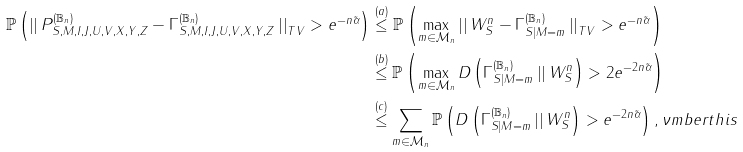Convert formula to latex. <formula><loc_0><loc_0><loc_500><loc_500>\mathbb { P } \left ( \left | \right | P ^ { ( \mathbb { B } _ { n } ) } _ { S , M , I , J , U , V , X , Y , Z } - \Gamma ^ { ( \mathbb { B } _ { n } ) } _ { S , M , I , J , U , V , X , Y , Z } \left | \right | _ { T V } > e ^ { - n \tilde { \alpha } } \right ) & \stackrel { ( a ) } \leq \mathbb { P } \left ( \max _ { m \in \mathcal { M } _ { n } } \left | \right | W _ { S } ^ { n } - \Gamma ^ { ( \mathbb { B } _ { n } ) } _ { S | M = m } \left | \right | _ { T V } > e ^ { - n \tilde { \alpha } } \right ) \\ & \stackrel { ( b ) } \leq \mathbb { P } \left ( \max _ { m \in \mathcal { M } _ { n } } D \left ( \Gamma ^ { ( \mathbb { B } _ { n } ) } _ { S | M = m } \left | \right | W _ { S } ^ { n } \right ) > 2 e ^ { - 2 n \tilde { \alpha } } \right ) \\ & \stackrel { ( c ) } \leq \sum _ { m \in \mathcal { M } _ { n } } \mathbb { P } \left ( D \left ( \Gamma ^ { ( \mathbb { B } _ { n } ) } _ { S | M = m } \left | \right | W _ { S } ^ { n } \right ) > e ^ { - 2 n \tilde { \alpha } } \right ) , \nu m b e r t h i s</formula> 